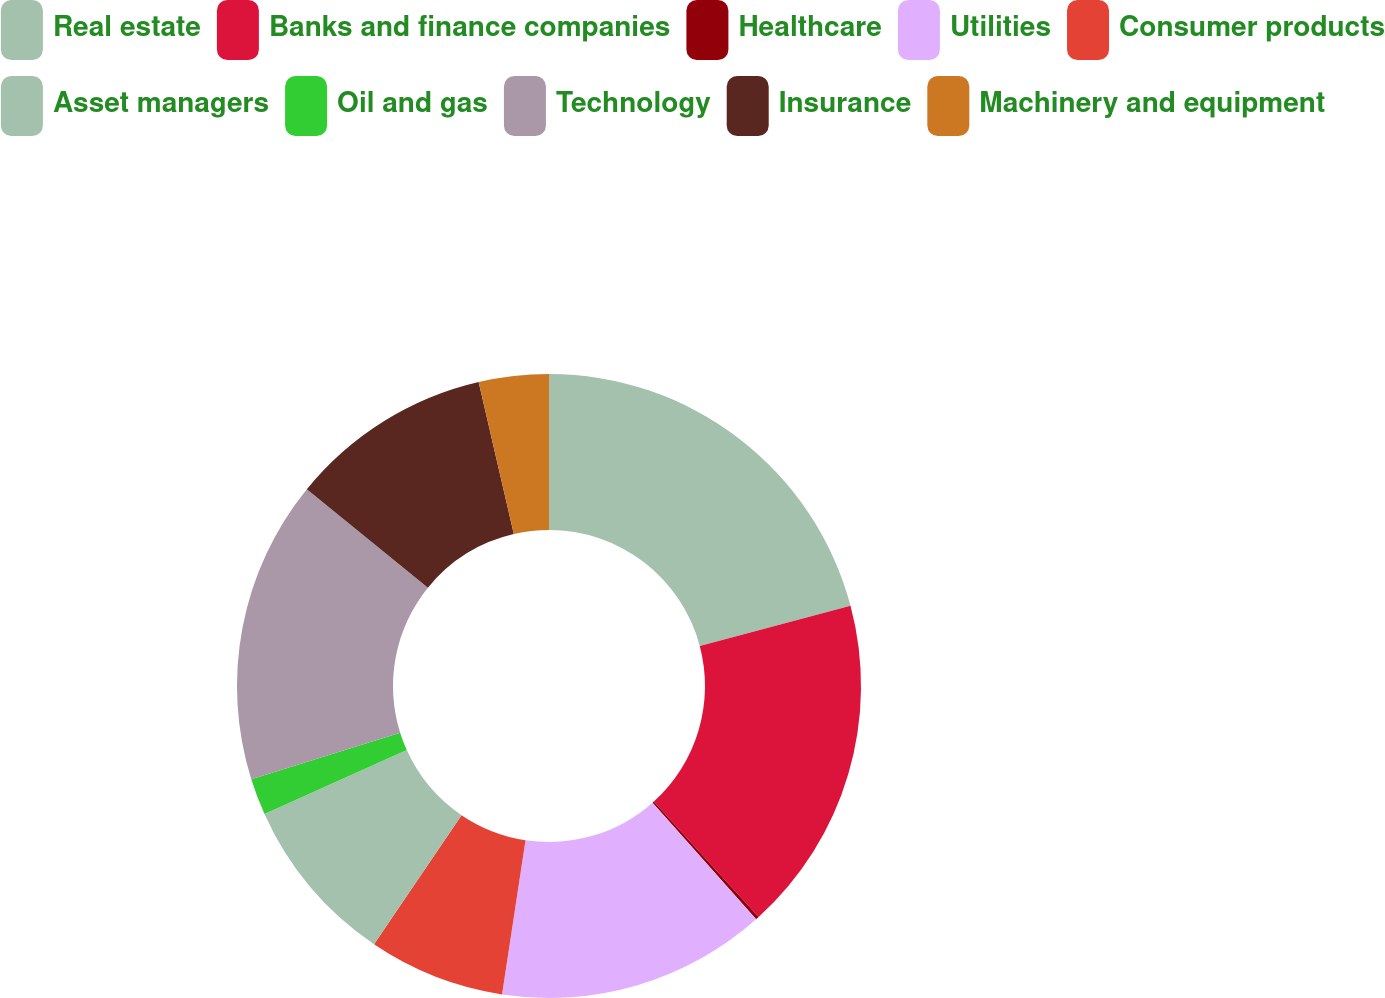Convert chart. <chart><loc_0><loc_0><loc_500><loc_500><pie_chart><fcel>Real estate<fcel>Banks and finance companies<fcel>Healthcare<fcel>Utilities<fcel>Consumer products<fcel>Asset managers<fcel>Oil and gas<fcel>Technology<fcel>Insurance<fcel>Machinery and equipment<nl><fcel>20.86%<fcel>17.41%<fcel>0.17%<fcel>13.96%<fcel>7.07%<fcel>8.79%<fcel>1.9%<fcel>15.69%<fcel>10.52%<fcel>3.62%<nl></chart> 